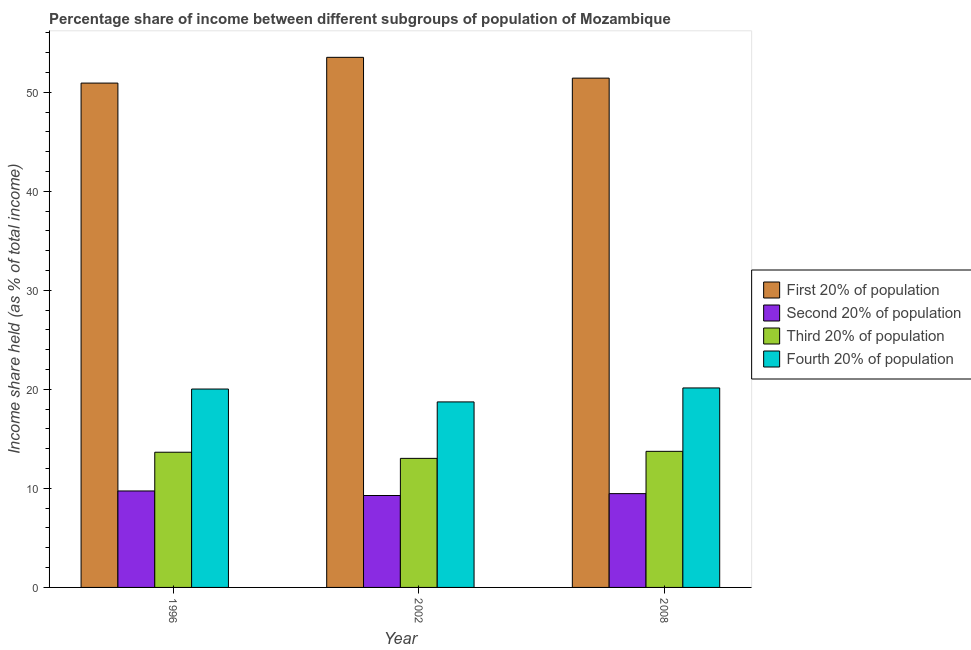How many different coloured bars are there?
Provide a short and direct response. 4. How many groups of bars are there?
Provide a short and direct response. 3. Are the number of bars on each tick of the X-axis equal?
Ensure brevity in your answer.  Yes. How many bars are there on the 3rd tick from the right?
Offer a terse response. 4. What is the label of the 1st group of bars from the left?
Your response must be concise. 1996. What is the share of the income held by first 20% of the population in 2002?
Provide a succinct answer. 53.52. Across all years, what is the maximum share of the income held by first 20% of the population?
Make the answer very short. 53.52. Across all years, what is the minimum share of the income held by first 20% of the population?
Provide a short and direct response. 50.92. In which year was the share of the income held by second 20% of the population minimum?
Offer a very short reply. 2002. What is the total share of the income held by third 20% of the population in the graph?
Offer a very short reply. 40.42. What is the difference between the share of the income held by fourth 20% of the population in 2002 and that in 2008?
Make the answer very short. -1.41. What is the difference between the share of the income held by fourth 20% of the population in 2008 and the share of the income held by second 20% of the population in 1996?
Your answer should be very brief. 0.11. What is the average share of the income held by first 20% of the population per year?
Offer a terse response. 51.95. In the year 2002, what is the difference between the share of the income held by fourth 20% of the population and share of the income held by first 20% of the population?
Ensure brevity in your answer.  0. What is the ratio of the share of the income held by fourth 20% of the population in 1996 to that in 2002?
Your answer should be compact. 1.07. Is the share of the income held by third 20% of the population in 2002 less than that in 2008?
Offer a terse response. Yes. Is the difference between the share of the income held by second 20% of the population in 1996 and 2002 greater than the difference between the share of the income held by first 20% of the population in 1996 and 2002?
Offer a very short reply. No. What is the difference between the highest and the second highest share of the income held by fourth 20% of the population?
Keep it short and to the point. 0.11. What is the difference between the highest and the lowest share of the income held by fourth 20% of the population?
Provide a short and direct response. 1.41. Is it the case that in every year, the sum of the share of the income held by first 20% of the population and share of the income held by second 20% of the population is greater than the sum of share of the income held by fourth 20% of the population and share of the income held by third 20% of the population?
Keep it short and to the point. Yes. What does the 2nd bar from the left in 1996 represents?
Offer a terse response. Second 20% of population. What does the 1st bar from the right in 1996 represents?
Provide a succinct answer. Fourth 20% of population. How many years are there in the graph?
Offer a terse response. 3. Does the graph contain grids?
Offer a very short reply. No. What is the title of the graph?
Keep it short and to the point. Percentage share of income between different subgroups of population of Mozambique. What is the label or title of the Y-axis?
Give a very brief answer. Income share held (as % of total income). What is the Income share held (as % of total income) in First 20% of population in 1996?
Offer a terse response. 50.92. What is the Income share held (as % of total income) of Second 20% of population in 1996?
Ensure brevity in your answer.  9.74. What is the Income share held (as % of total income) of Third 20% of population in 1996?
Offer a very short reply. 13.65. What is the Income share held (as % of total income) in Fourth 20% of population in 1996?
Your response must be concise. 20.03. What is the Income share held (as % of total income) of First 20% of population in 2002?
Provide a short and direct response. 53.52. What is the Income share held (as % of total income) of Second 20% of population in 2002?
Keep it short and to the point. 9.28. What is the Income share held (as % of total income) in Third 20% of population in 2002?
Make the answer very short. 13.03. What is the Income share held (as % of total income) of Fourth 20% of population in 2002?
Keep it short and to the point. 18.73. What is the Income share held (as % of total income) in First 20% of population in 2008?
Give a very brief answer. 51.42. What is the Income share held (as % of total income) of Second 20% of population in 2008?
Provide a succinct answer. 9.47. What is the Income share held (as % of total income) in Third 20% of population in 2008?
Ensure brevity in your answer.  13.74. What is the Income share held (as % of total income) in Fourth 20% of population in 2008?
Offer a very short reply. 20.14. Across all years, what is the maximum Income share held (as % of total income) in First 20% of population?
Your answer should be very brief. 53.52. Across all years, what is the maximum Income share held (as % of total income) of Second 20% of population?
Provide a succinct answer. 9.74. Across all years, what is the maximum Income share held (as % of total income) of Third 20% of population?
Offer a very short reply. 13.74. Across all years, what is the maximum Income share held (as % of total income) of Fourth 20% of population?
Give a very brief answer. 20.14. Across all years, what is the minimum Income share held (as % of total income) of First 20% of population?
Provide a short and direct response. 50.92. Across all years, what is the minimum Income share held (as % of total income) in Second 20% of population?
Give a very brief answer. 9.28. Across all years, what is the minimum Income share held (as % of total income) of Third 20% of population?
Ensure brevity in your answer.  13.03. Across all years, what is the minimum Income share held (as % of total income) of Fourth 20% of population?
Keep it short and to the point. 18.73. What is the total Income share held (as % of total income) of First 20% of population in the graph?
Make the answer very short. 155.86. What is the total Income share held (as % of total income) of Second 20% of population in the graph?
Offer a very short reply. 28.49. What is the total Income share held (as % of total income) in Third 20% of population in the graph?
Keep it short and to the point. 40.42. What is the total Income share held (as % of total income) in Fourth 20% of population in the graph?
Provide a short and direct response. 58.9. What is the difference between the Income share held (as % of total income) of First 20% of population in 1996 and that in 2002?
Provide a succinct answer. -2.6. What is the difference between the Income share held (as % of total income) of Second 20% of population in 1996 and that in 2002?
Your response must be concise. 0.46. What is the difference between the Income share held (as % of total income) of Third 20% of population in 1996 and that in 2002?
Your answer should be very brief. 0.62. What is the difference between the Income share held (as % of total income) of Second 20% of population in 1996 and that in 2008?
Provide a short and direct response. 0.27. What is the difference between the Income share held (as % of total income) of Third 20% of population in 1996 and that in 2008?
Provide a succinct answer. -0.09. What is the difference between the Income share held (as % of total income) in Fourth 20% of population in 1996 and that in 2008?
Make the answer very short. -0.11. What is the difference between the Income share held (as % of total income) of Second 20% of population in 2002 and that in 2008?
Offer a very short reply. -0.19. What is the difference between the Income share held (as % of total income) of Third 20% of population in 2002 and that in 2008?
Ensure brevity in your answer.  -0.71. What is the difference between the Income share held (as % of total income) of Fourth 20% of population in 2002 and that in 2008?
Offer a terse response. -1.41. What is the difference between the Income share held (as % of total income) of First 20% of population in 1996 and the Income share held (as % of total income) of Second 20% of population in 2002?
Make the answer very short. 41.64. What is the difference between the Income share held (as % of total income) in First 20% of population in 1996 and the Income share held (as % of total income) in Third 20% of population in 2002?
Make the answer very short. 37.89. What is the difference between the Income share held (as % of total income) in First 20% of population in 1996 and the Income share held (as % of total income) in Fourth 20% of population in 2002?
Make the answer very short. 32.19. What is the difference between the Income share held (as % of total income) of Second 20% of population in 1996 and the Income share held (as % of total income) of Third 20% of population in 2002?
Make the answer very short. -3.29. What is the difference between the Income share held (as % of total income) of Second 20% of population in 1996 and the Income share held (as % of total income) of Fourth 20% of population in 2002?
Make the answer very short. -8.99. What is the difference between the Income share held (as % of total income) in Third 20% of population in 1996 and the Income share held (as % of total income) in Fourth 20% of population in 2002?
Provide a succinct answer. -5.08. What is the difference between the Income share held (as % of total income) in First 20% of population in 1996 and the Income share held (as % of total income) in Second 20% of population in 2008?
Your answer should be compact. 41.45. What is the difference between the Income share held (as % of total income) in First 20% of population in 1996 and the Income share held (as % of total income) in Third 20% of population in 2008?
Provide a succinct answer. 37.18. What is the difference between the Income share held (as % of total income) in First 20% of population in 1996 and the Income share held (as % of total income) in Fourth 20% of population in 2008?
Provide a short and direct response. 30.78. What is the difference between the Income share held (as % of total income) of Second 20% of population in 1996 and the Income share held (as % of total income) of Fourth 20% of population in 2008?
Offer a very short reply. -10.4. What is the difference between the Income share held (as % of total income) in Third 20% of population in 1996 and the Income share held (as % of total income) in Fourth 20% of population in 2008?
Offer a very short reply. -6.49. What is the difference between the Income share held (as % of total income) in First 20% of population in 2002 and the Income share held (as % of total income) in Second 20% of population in 2008?
Provide a short and direct response. 44.05. What is the difference between the Income share held (as % of total income) in First 20% of population in 2002 and the Income share held (as % of total income) in Third 20% of population in 2008?
Keep it short and to the point. 39.78. What is the difference between the Income share held (as % of total income) of First 20% of population in 2002 and the Income share held (as % of total income) of Fourth 20% of population in 2008?
Provide a succinct answer. 33.38. What is the difference between the Income share held (as % of total income) of Second 20% of population in 2002 and the Income share held (as % of total income) of Third 20% of population in 2008?
Provide a succinct answer. -4.46. What is the difference between the Income share held (as % of total income) of Second 20% of population in 2002 and the Income share held (as % of total income) of Fourth 20% of population in 2008?
Offer a terse response. -10.86. What is the difference between the Income share held (as % of total income) of Third 20% of population in 2002 and the Income share held (as % of total income) of Fourth 20% of population in 2008?
Your answer should be compact. -7.11. What is the average Income share held (as % of total income) in First 20% of population per year?
Offer a very short reply. 51.95. What is the average Income share held (as % of total income) of Second 20% of population per year?
Keep it short and to the point. 9.5. What is the average Income share held (as % of total income) of Third 20% of population per year?
Give a very brief answer. 13.47. What is the average Income share held (as % of total income) in Fourth 20% of population per year?
Your response must be concise. 19.63. In the year 1996, what is the difference between the Income share held (as % of total income) of First 20% of population and Income share held (as % of total income) of Second 20% of population?
Keep it short and to the point. 41.18. In the year 1996, what is the difference between the Income share held (as % of total income) in First 20% of population and Income share held (as % of total income) in Third 20% of population?
Ensure brevity in your answer.  37.27. In the year 1996, what is the difference between the Income share held (as % of total income) in First 20% of population and Income share held (as % of total income) in Fourth 20% of population?
Ensure brevity in your answer.  30.89. In the year 1996, what is the difference between the Income share held (as % of total income) in Second 20% of population and Income share held (as % of total income) in Third 20% of population?
Your response must be concise. -3.91. In the year 1996, what is the difference between the Income share held (as % of total income) of Second 20% of population and Income share held (as % of total income) of Fourth 20% of population?
Give a very brief answer. -10.29. In the year 1996, what is the difference between the Income share held (as % of total income) in Third 20% of population and Income share held (as % of total income) in Fourth 20% of population?
Offer a very short reply. -6.38. In the year 2002, what is the difference between the Income share held (as % of total income) in First 20% of population and Income share held (as % of total income) in Second 20% of population?
Keep it short and to the point. 44.24. In the year 2002, what is the difference between the Income share held (as % of total income) of First 20% of population and Income share held (as % of total income) of Third 20% of population?
Provide a short and direct response. 40.49. In the year 2002, what is the difference between the Income share held (as % of total income) of First 20% of population and Income share held (as % of total income) of Fourth 20% of population?
Offer a terse response. 34.79. In the year 2002, what is the difference between the Income share held (as % of total income) in Second 20% of population and Income share held (as % of total income) in Third 20% of population?
Give a very brief answer. -3.75. In the year 2002, what is the difference between the Income share held (as % of total income) in Second 20% of population and Income share held (as % of total income) in Fourth 20% of population?
Provide a short and direct response. -9.45. In the year 2002, what is the difference between the Income share held (as % of total income) of Third 20% of population and Income share held (as % of total income) of Fourth 20% of population?
Provide a succinct answer. -5.7. In the year 2008, what is the difference between the Income share held (as % of total income) in First 20% of population and Income share held (as % of total income) in Second 20% of population?
Ensure brevity in your answer.  41.95. In the year 2008, what is the difference between the Income share held (as % of total income) of First 20% of population and Income share held (as % of total income) of Third 20% of population?
Offer a very short reply. 37.68. In the year 2008, what is the difference between the Income share held (as % of total income) of First 20% of population and Income share held (as % of total income) of Fourth 20% of population?
Ensure brevity in your answer.  31.28. In the year 2008, what is the difference between the Income share held (as % of total income) of Second 20% of population and Income share held (as % of total income) of Third 20% of population?
Make the answer very short. -4.27. In the year 2008, what is the difference between the Income share held (as % of total income) of Second 20% of population and Income share held (as % of total income) of Fourth 20% of population?
Make the answer very short. -10.67. In the year 2008, what is the difference between the Income share held (as % of total income) in Third 20% of population and Income share held (as % of total income) in Fourth 20% of population?
Offer a very short reply. -6.4. What is the ratio of the Income share held (as % of total income) in First 20% of population in 1996 to that in 2002?
Ensure brevity in your answer.  0.95. What is the ratio of the Income share held (as % of total income) of Second 20% of population in 1996 to that in 2002?
Offer a very short reply. 1.05. What is the ratio of the Income share held (as % of total income) in Third 20% of population in 1996 to that in 2002?
Give a very brief answer. 1.05. What is the ratio of the Income share held (as % of total income) of Fourth 20% of population in 1996 to that in 2002?
Ensure brevity in your answer.  1.07. What is the ratio of the Income share held (as % of total income) of First 20% of population in 1996 to that in 2008?
Ensure brevity in your answer.  0.99. What is the ratio of the Income share held (as % of total income) of Second 20% of population in 1996 to that in 2008?
Give a very brief answer. 1.03. What is the ratio of the Income share held (as % of total income) in Fourth 20% of population in 1996 to that in 2008?
Provide a succinct answer. 0.99. What is the ratio of the Income share held (as % of total income) in First 20% of population in 2002 to that in 2008?
Offer a very short reply. 1.04. What is the ratio of the Income share held (as % of total income) of Second 20% of population in 2002 to that in 2008?
Your response must be concise. 0.98. What is the ratio of the Income share held (as % of total income) of Third 20% of population in 2002 to that in 2008?
Your answer should be very brief. 0.95. What is the ratio of the Income share held (as % of total income) of Fourth 20% of population in 2002 to that in 2008?
Make the answer very short. 0.93. What is the difference between the highest and the second highest Income share held (as % of total income) of Second 20% of population?
Make the answer very short. 0.27. What is the difference between the highest and the second highest Income share held (as % of total income) in Third 20% of population?
Your answer should be very brief. 0.09. What is the difference between the highest and the second highest Income share held (as % of total income) in Fourth 20% of population?
Keep it short and to the point. 0.11. What is the difference between the highest and the lowest Income share held (as % of total income) in First 20% of population?
Make the answer very short. 2.6. What is the difference between the highest and the lowest Income share held (as % of total income) of Second 20% of population?
Give a very brief answer. 0.46. What is the difference between the highest and the lowest Income share held (as % of total income) of Third 20% of population?
Make the answer very short. 0.71. What is the difference between the highest and the lowest Income share held (as % of total income) in Fourth 20% of population?
Provide a short and direct response. 1.41. 